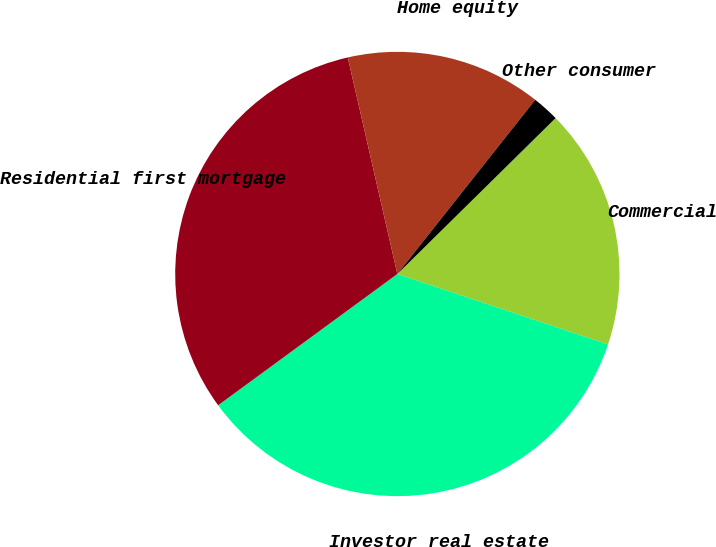Convert chart. <chart><loc_0><loc_0><loc_500><loc_500><pie_chart><fcel>Commercial<fcel>Investor real estate<fcel>Residential first mortgage<fcel>Home equity<fcel>Other consumer<nl><fcel>17.52%<fcel>34.8%<fcel>31.48%<fcel>14.24%<fcel>1.96%<nl></chart> 